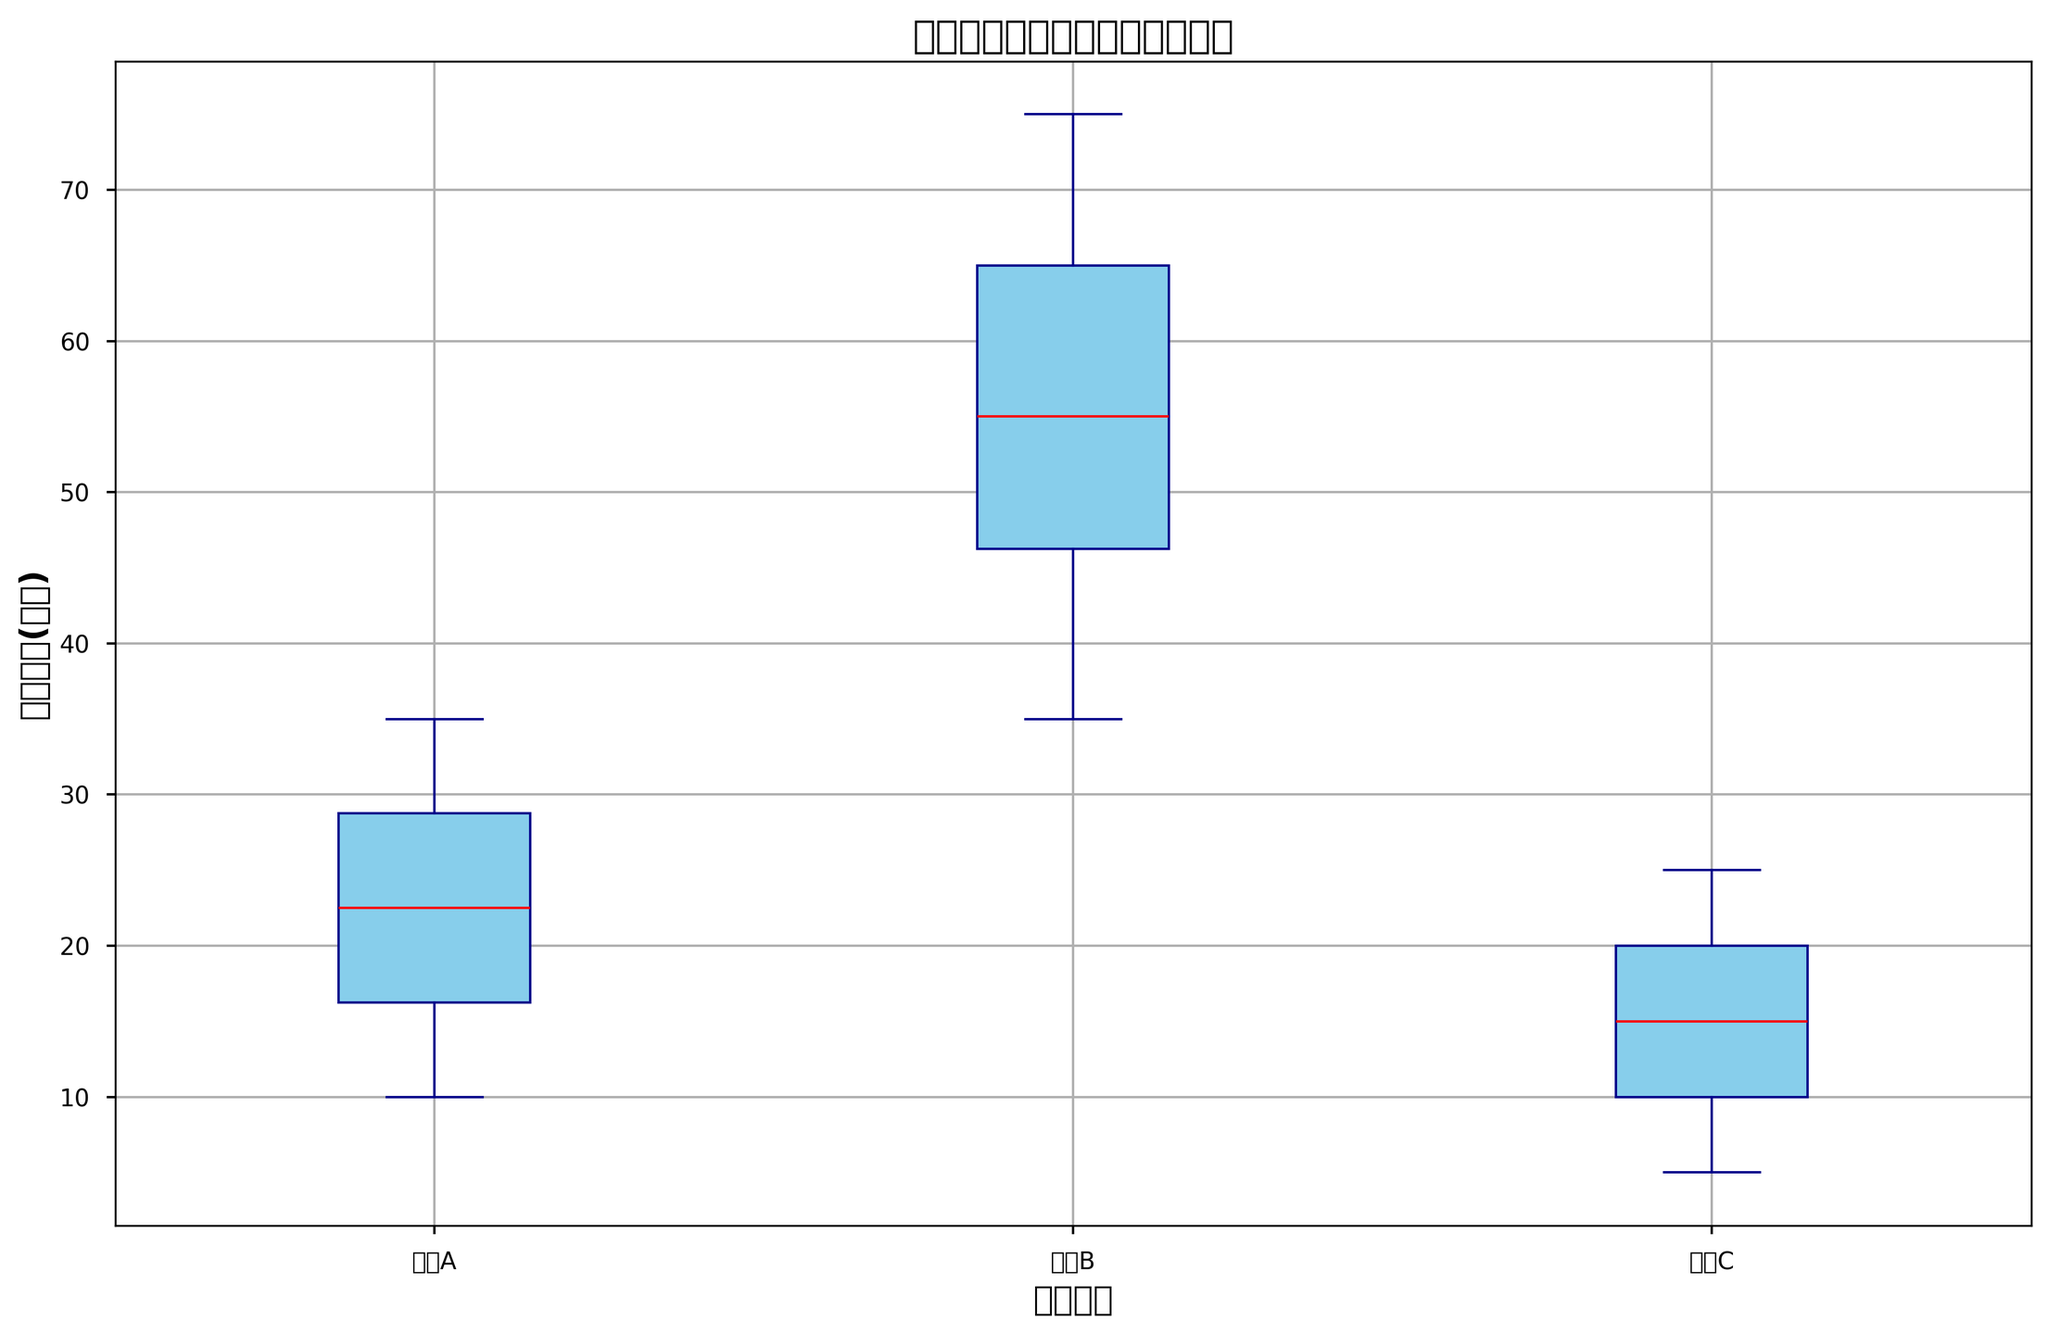What's the median等待时间(分钟) for医院A? To find the median, we arrange the等待时间 values for医院A in ascending order: 10, 15, 15, 20, 20, 25, 25, 30, 30, 35. The median is the middle value, which is the average of the 5th and 6th values: (20+25)/2.
Answer: 22.5 How does the median等待时间(分钟) for医院B compare to that of诊所C? The box plots show that the median line inside the box for医院B is around 55 minutes and for诊所C is around 15 minutes. 医院B has a much higher median.
Answer: 医院B has a higher median Which医疗机构 has the widest range of等待时间(分钟)? The range is the difference between the maximum and minimum values. For医院B, the range appears to be the widest, from around 35 to 75 minutes based on the box plot's whiskers.
Answer: 医院B What is the interquartile range (IQR) of等待时间(分钟) for诊所C? The IQR is the difference between the first and third quartiles (the bottom and top edges of the box). For诊所C, the IQR seems to be from about 10 to 20 minutes, so IQR = 20 - 10.
Answer: 10 Which医疗机构 has the highest median患者满意度? Although the box plot doesn't show患者满意度, based on other info, we can infer 诊所C, as it has shorter waiting times and generally higher satisfaction correlated with shorter waits.
Answer: 诊所C Does医院A have any outliers in等待时间(分钟)? Outliers are typically represented by points outside the whiskers of the box plot. 医院A does not seem to display any outliers in its plot.
Answer: No What is the maximum等待时间(分钟) for医院B? The maximum value is marked by the top whisker of the box plot for医院B, which seems to reach 75 minutes.
Answer: 75 How do the upper quartiles (75th percentile) compare between医院A and诊所C? The upper quartile for医院A is around 30 minutes, and for诊所C it is about 20 minutes. Thus,医院A has a higher upper quartile.
Answer: 医院A has a higher upper quartile What's the median difference in等待时间(分钟) between医院A and医院B? The median for医院A is 22.5 minutes and for医院B is around 55 minutes. The difference is 55 - 22.5.
Answer: 32.5 How do the whisker lengths compare between医院A and诊所C? The whiskers represent the range of the distribution. For医院A, the whiskers extend from around 10 to 35 minutes, a spread of 25 minutes. For诊所C, the whiskers extend from about 5 to 25 minutes, a spread of 20 minutes. 医院A has slightly longer whiskers.
Answer: 医院A has slightly longer whiskers 